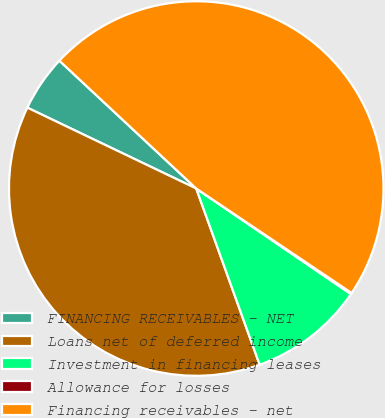Convert chart to OTSL. <chart><loc_0><loc_0><loc_500><loc_500><pie_chart><fcel>FINANCING RECEIVABLES - NET<fcel>Loans net of deferred income<fcel>Investment in financing leases<fcel>Allowance for losses<fcel>Financing receivables - net<nl><fcel>4.85%<fcel>37.61%<fcel>9.97%<fcel>0.11%<fcel>47.47%<nl></chart> 